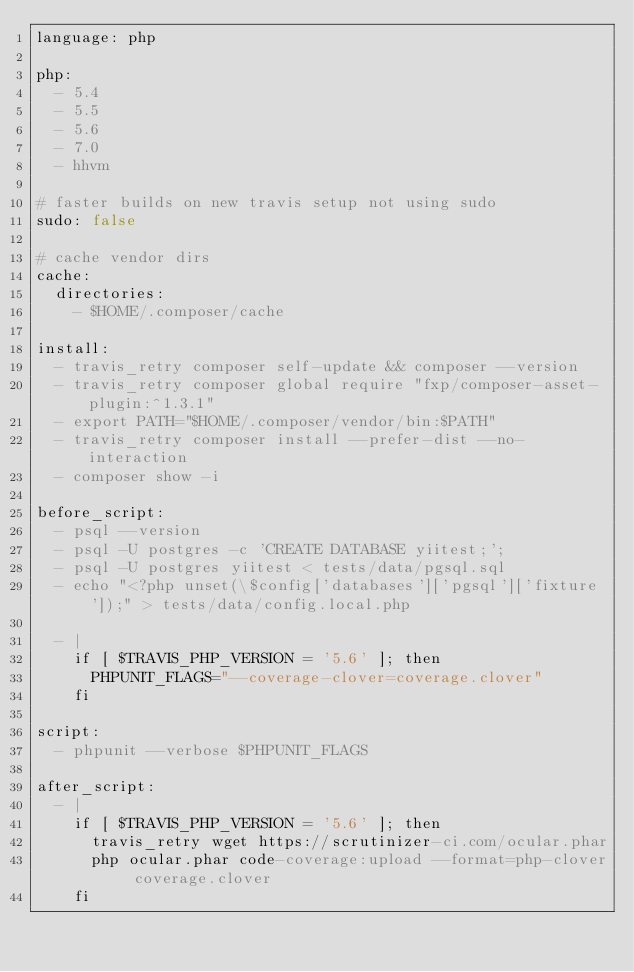Convert code to text. <code><loc_0><loc_0><loc_500><loc_500><_YAML_>language: php

php:
  - 5.4
  - 5.5
  - 5.6
  - 7.0
  - hhvm

# faster builds on new travis setup not using sudo
sudo: false

# cache vendor dirs
cache:
  directories:
    - $HOME/.composer/cache

install:
  - travis_retry composer self-update && composer --version
  - travis_retry composer global require "fxp/composer-asset-plugin:^1.3.1"
  - export PATH="$HOME/.composer/vendor/bin:$PATH"
  - travis_retry composer install --prefer-dist --no-interaction
  - composer show -i

before_script:
  - psql --version
  - psql -U postgres -c 'CREATE DATABASE yiitest;';
  - psql -U postgres yiitest < tests/data/pgsql.sql
  - echo "<?php unset(\$config['databases']['pgsql']['fixture']);" > tests/data/config.local.php

  - |
    if [ $TRAVIS_PHP_VERSION = '5.6' ]; then
      PHPUNIT_FLAGS="--coverage-clover=coverage.clover"
    fi

script:
  - phpunit --verbose $PHPUNIT_FLAGS

after_script:
  - |
    if [ $TRAVIS_PHP_VERSION = '5.6' ]; then
      travis_retry wget https://scrutinizer-ci.com/ocular.phar
      php ocular.phar code-coverage:upload --format=php-clover coverage.clover
    fi
</code> 